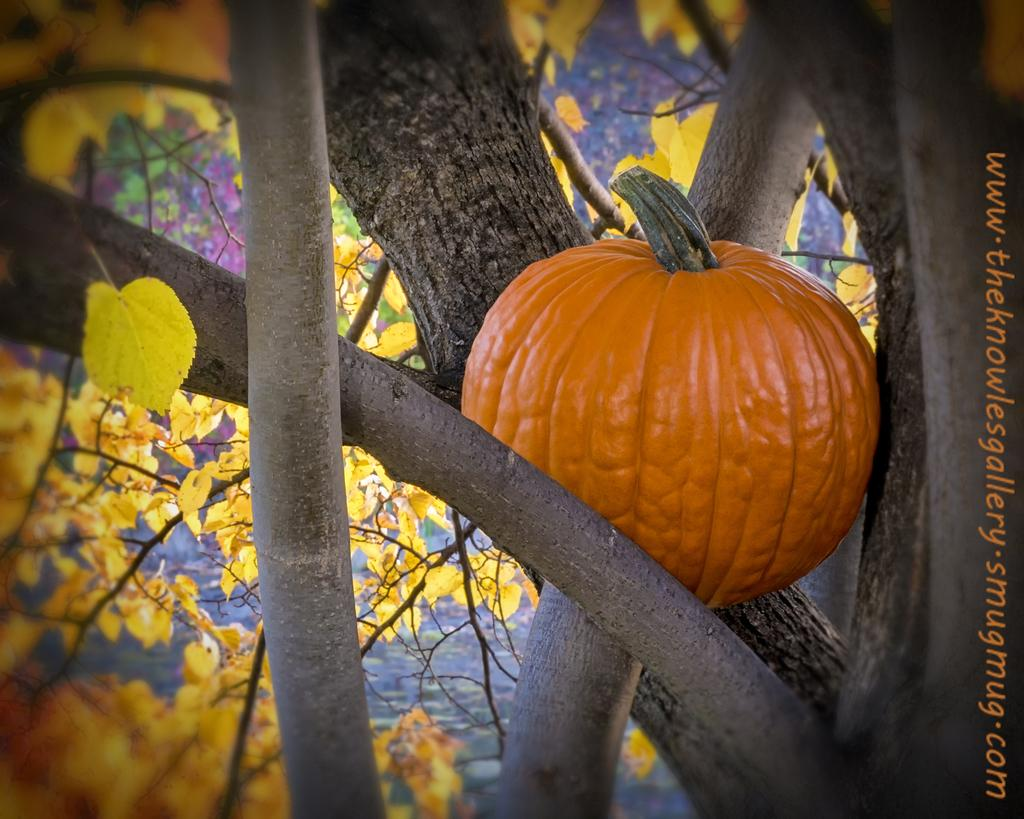What object can be seen in the image? There is a pumpkin in the image. What is the color of the pumpkin? The pumpkin is orange in color. Where is the pumpkin located in the image? The pumpkin is in the branches of a tree. What else can be seen in the image besides the pumpkin? There are leaves visible in the image. What type of stone can be seen in the aftermath of the pumpkin's impact with the ground? There is no stone or impact with the ground mentioned in the image; the pumpkin is simply located in the branches of a tree. 